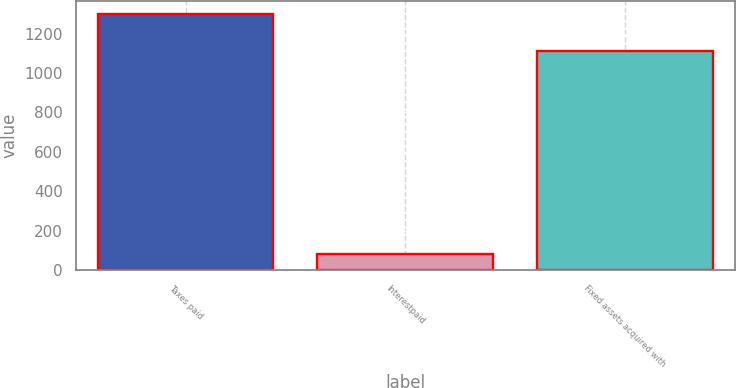<chart> <loc_0><loc_0><loc_500><loc_500><bar_chart><fcel>Taxes paid<fcel>Interestpaid<fcel>Fixed assets acquired with<nl><fcel>1298<fcel>80<fcel>1112<nl></chart> 